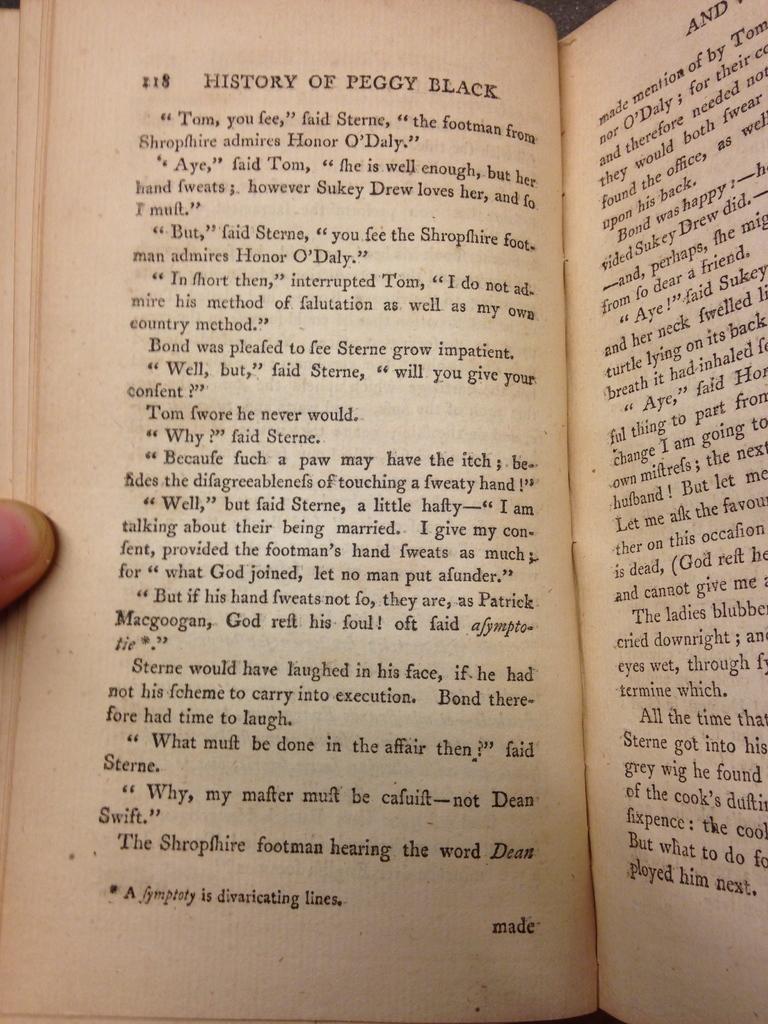What is the title on the top of the page?
Make the answer very short. History of peggy black. What page number is on the left?
Your answer should be compact. 218. 